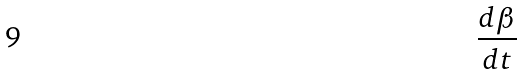Convert formula to latex. <formula><loc_0><loc_0><loc_500><loc_500>\frac { d \beta } { d t }</formula> 